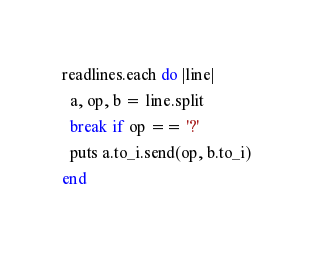<code> <loc_0><loc_0><loc_500><loc_500><_Ruby_>readlines.each do |line|
  a, op, b = line.split
  break if op == '?'
  puts a.to_i.send(op, b.to_i)
end</code> 